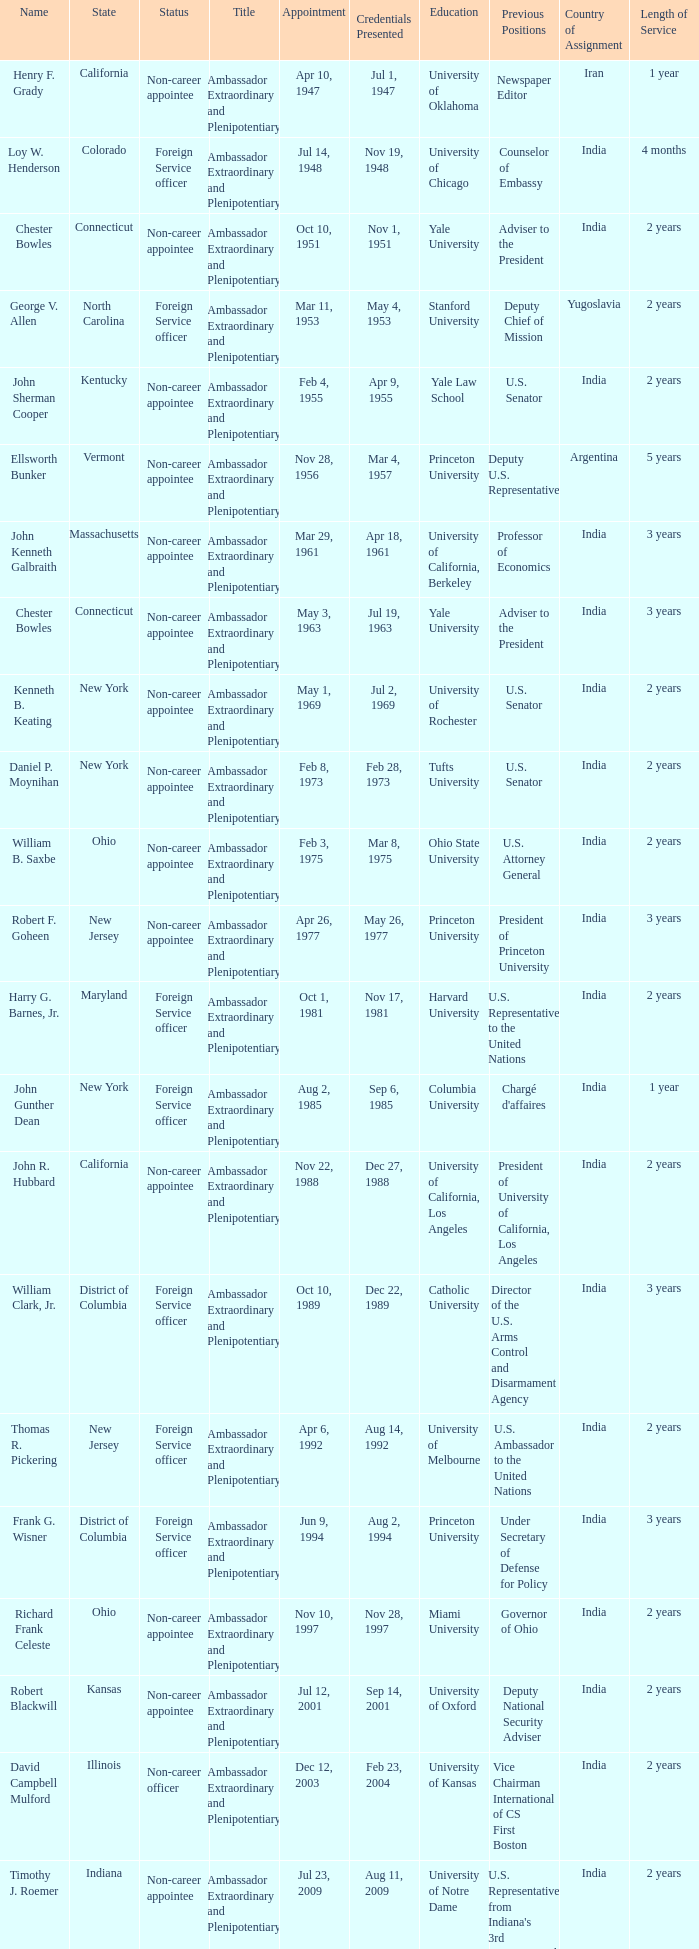When were the credentials presented for new jersey with a status of foreign service officer? Aug 14, 1992. 